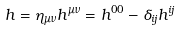Convert formula to latex. <formula><loc_0><loc_0><loc_500><loc_500>h = \eta _ { \mu \nu } h ^ { \mu \nu } = h ^ { 0 0 } - \delta _ { i j } h ^ { i j }</formula> 